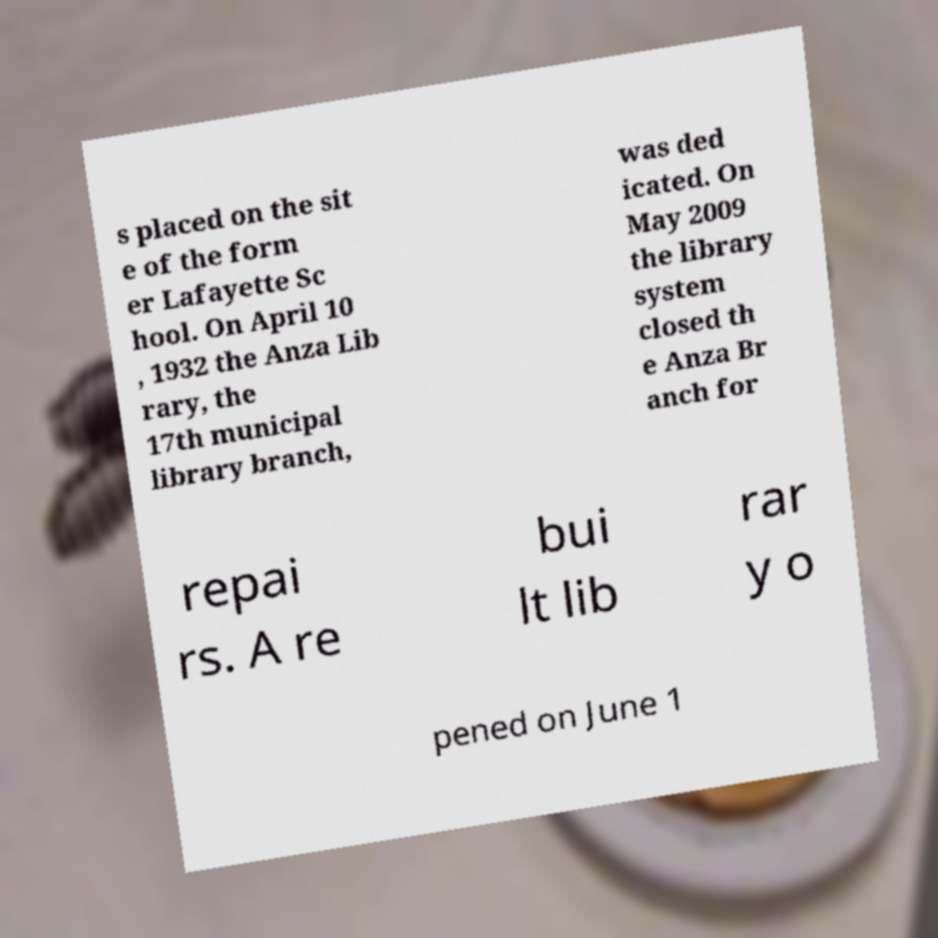Please identify and transcribe the text found in this image. s placed on the sit e of the form er Lafayette Sc hool. On April 10 , 1932 the Anza Lib rary, the 17th municipal library branch, was ded icated. On May 2009 the library system closed th e Anza Br anch for repai rs. A re bui lt lib rar y o pened on June 1 